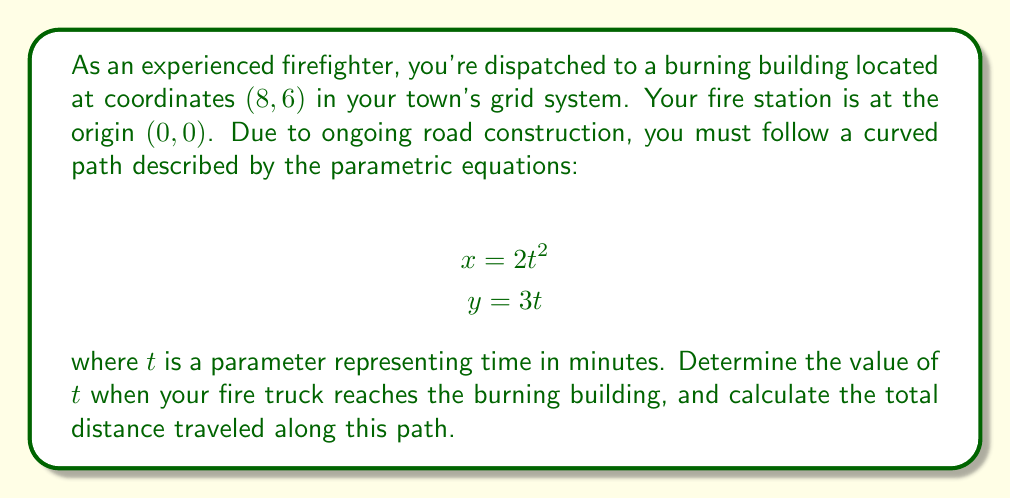Could you help me with this problem? To solve this problem, we'll follow these steps:

1) First, we need to find the value of $t$ when the fire truck reaches the burning building. We can do this by solving the system of equations:

   $$8 = 2t^2$$
   $$6 = 3t$$

2) From the second equation, we can easily solve for $t$:
   
   $$t = \frac{6}{3} = 2$$

3) We can verify this solution in the first equation:
   
   $$8 = 2(2)^2 = 2(4) = 8$$

   So, $t = 2$ is indeed the correct solution.

4) Now that we know $t = 2$, we need to calculate the total distance traveled along the path. For parametric equations, we can use the arc length formula:

   $$L = \int_0^2 \sqrt{\left(\frac{dx}{dt}\right)^2 + \left(\frac{dy}{dt}\right)^2} dt$$

5) Let's find $\frac{dx}{dt}$ and $\frac{dy}{dt}$:
   
   $$\frac{dx}{dt} = 4t$$
   $$\frac{dy}{dt} = 3$$

6) Substituting these into our arc length formula:

   $$L = \int_0^2 \sqrt{(4t)^2 + 3^2} dt = \int_0^2 \sqrt{16t^2 + 9} dt$$

7) This integral is challenging to solve analytically. We can use numerical integration methods or a calculator with integration capabilities to find the result:

   $$L \approx 10.27$$

Therefore, the fire truck reaches the burning building after 2 minutes and travels approximately 10.27 units of distance along its path.
Answer: The fire truck reaches the burning building when $t = 2$ minutes, and the total distance traveled is approximately 10.27 units. 